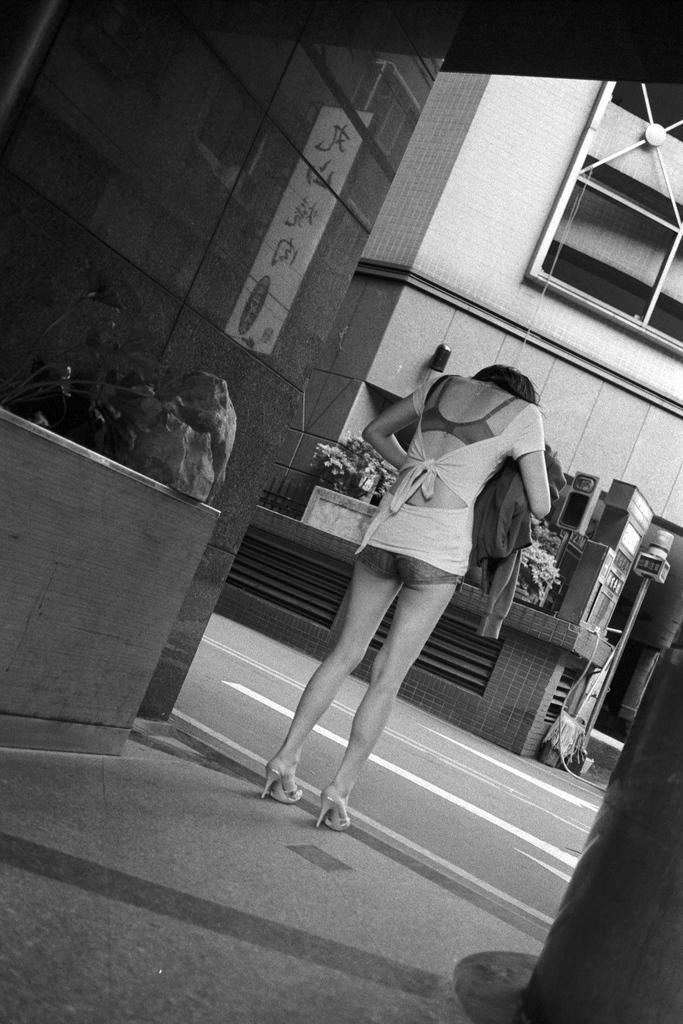In one or two sentences, can you explain what this image depicts? In the center of the image, we can see a lady holding a coat and in the background, there are flower pots and we can see buildings. At the bottom, there is road. 